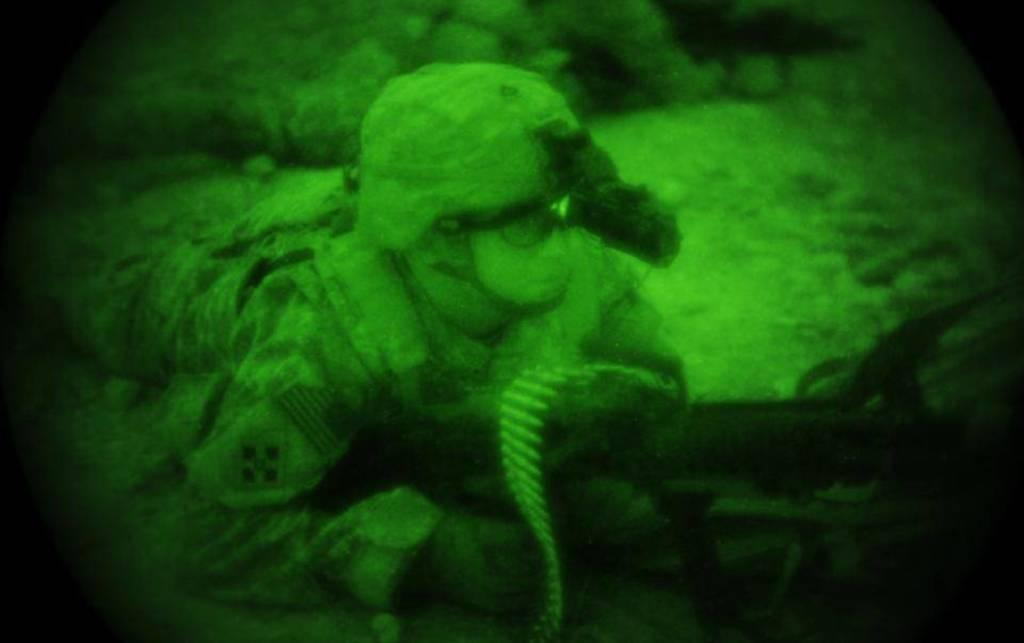Who is the main subject in the image? There is a person in the center of the image. What is the person doing in the image? The person is lying down. What is the person holding in the image? The person is holding a gun. What type of headwear is the person wearing in the image? The person is wearing a hat. What can be seen in the background of the image? There are other objects in the background of the image. How does the person wash their hands in the image? There is no indication in the image that the person is washing their hands, as they are lying down and holding a gun. What type of leaf can be seen falling from the hat in the image? There is no leaf present in the image, and the person's hat does not appear to be falling off. 